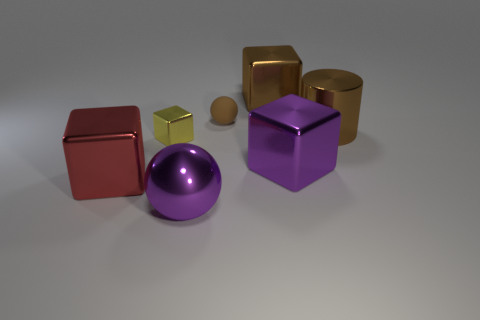Subtract all small shiny cubes. How many cubes are left? 3 Subtract all yellow cubes. How many cubes are left? 3 Add 3 small matte spheres. How many objects exist? 10 Subtract 3 cubes. How many cubes are left? 1 Subtract 0 green cylinders. How many objects are left? 7 Subtract all cylinders. How many objects are left? 6 Subtract all green cylinders. Subtract all purple spheres. How many cylinders are left? 1 Subtract all purple objects. Subtract all rubber balls. How many objects are left? 4 Add 3 tiny yellow shiny blocks. How many tiny yellow shiny blocks are left? 4 Add 3 cyan metal objects. How many cyan metal objects exist? 3 